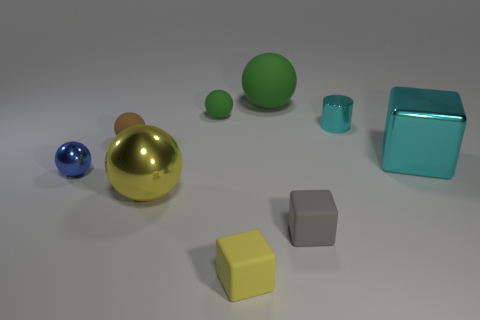How many things are either tiny things left of the yellow rubber thing or cyan shiny blocks?
Offer a very short reply. 4. There is a tiny metal object that is on the right side of the large ball that is behind the large yellow metal sphere; what is its shape?
Your answer should be very brief. Cylinder. Are there any blue balls of the same size as the blue thing?
Keep it short and to the point. No. Is the number of big yellow blocks greater than the number of small brown matte objects?
Your answer should be very brief. No. There is a cyan metallic thing left of the large cyan object; does it have the same size as the ball that is in front of the small blue metal sphere?
Your answer should be compact. No. What number of balls are both right of the small brown matte object and in front of the tiny green matte sphere?
Your answer should be very brief. 1. There is a big rubber object that is the same shape as the large yellow metal thing; what is its color?
Provide a short and direct response. Green. Are there fewer big yellow metal balls than large spheres?
Provide a succinct answer. Yes. There is a cyan cube; is its size the same as the sphere that is in front of the tiny blue shiny thing?
Offer a terse response. Yes. What color is the tiny matte ball that is left of the big object in front of the big cyan cube?
Ensure brevity in your answer.  Brown. 